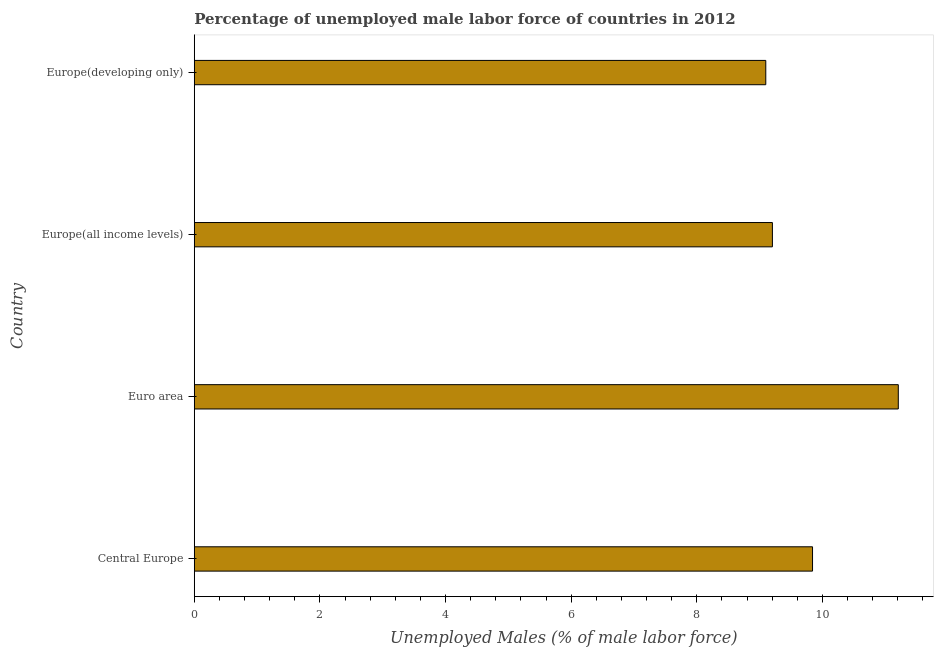Does the graph contain grids?
Your answer should be compact. No. What is the title of the graph?
Keep it short and to the point. Percentage of unemployed male labor force of countries in 2012. What is the label or title of the X-axis?
Your response must be concise. Unemployed Males (% of male labor force). What is the total unemployed male labour force in Euro area?
Offer a terse response. 11.21. Across all countries, what is the maximum total unemployed male labour force?
Keep it short and to the point. 11.21. Across all countries, what is the minimum total unemployed male labour force?
Keep it short and to the point. 9.1. In which country was the total unemployed male labour force minimum?
Make the answer very short. Europe(developing only). What is the sum of the total unemployed male labour force?
Make the answer very short. 39.35. What is the difference between the total unemployed male labour force in Europe(all income levels) and Europe(developing only)?
Offer a terse response. 0.1. What is the average total unemployed male labour force per country?
Your answer should be very brief. 9.84. What is the median total unemployed male labour force?
Provide a short and direct response. 9.52. In how many countries, is the total unemployed male labour force greater than 7.2 %?
Keep it short and to the point. 4. What is the ratio of the total unemployed male labour force in Central Europe to that in Europe(developing only)?
Your response must be concise. 1.08. Is the total unemployed male labour force in Europe(all income levels) less than that in Europe(developing only)?
Ensure brevity in your answer.  No. Is the difference between the total unemployed male labour force in Euro area and Europe(developing only) greater than the difference between any two countries?
Your answer should be compact. Yes. What is the difference between the highest and the second highest total unemployed male labour force?
Give a very brief answer. 1.36. Is the sum of the total unemployed male labour force in Euro area and Europe(all income levels) greater than the maximum total unemployed male labour force across all countries?
Ensure brevity in your answer.  Yes. What is the difference between the highest and the lowest total unemployed male labour force?
Provide a succinct answer. 2.11. In how many countries, is the total unemployed male labour force greater than the average total unemployed male labour force taken over all countries?
Make the answer very short. 2. How many bars are there?
Provide a short and direct response. 4. Are all the bars in the graph horizontal?
Your answer should be compact. Yes. How many countries are there in the graph?
Your answer should be very brief. 4. What is the difference between two consecutive major ticks on the X-axis?
Make the answer very short. 2. What is the Unemployed Males (% of male labor force) in Central Europe?
Keep it short and to the point. 9.84. What is the Unemployed Males (% of male labor force) in Euro area?
Offer a very short reply. 11.21. What is the Unemployed Males (% of male labor force) in Europe(all income levels)?
Your answer should be compact. 9.2. What is the Unemployed Males (% of male labor force) of Europe(developing only)?
Ensure brevity in your answer.  9.1. What is the difference between the Unemployed Males (% of male labor force) in Central Europe and Euro area?
Your answer should be very brief. -1.37. What is the difference between the Unemployed Males (% of male labor force) in Central Europe and Europe(all income levels)?
Offer a terse response. 0.64. What is the difference between the Unemployed Males (% of male labor force) in Central Europe and Europe(developing only)?
Keep it short and to the point. 0.74. What is the difference between the Unemployed Males (% of male labor force) in Euro area and Europe(all income levels)?
Make the answer very short. 2. What is the difference between the Unemployed Males (% of male labor force) in Euro area and Europe(developing only)?
Provide a short and direct response. 2.11. What is the difference between the Unemployed Males (% of male labor force) in Europe(all income levels) and Europe(developing only)?
Offer a very short reply. 0.11. What is the ratio of the Unemployed Males (% of male labor force) in Central Europe to that in Euro area?
Your answer should be very brief. 0.88. What is the ratio of the Unemployed Males (% of male labor force) in Central Europe to that in Europe(all income levels)?
Offer a terse response. 1.07. What is the ratio of the Unemployed Males (% of male labor force) in Central Europe to that in Europe(developing only)?
Provide a succinct answer. 1.08. What is the ratio of the Unemployed Males (% of male labor force) in Euro area to that in Europe(all income levels)?
Give a very brief answer. 1.22. What is the ratio of the Unemployed Males (% of male labor force) in Euro area to that in Europe(developing only)?
Offer a terse response. 1.23. 